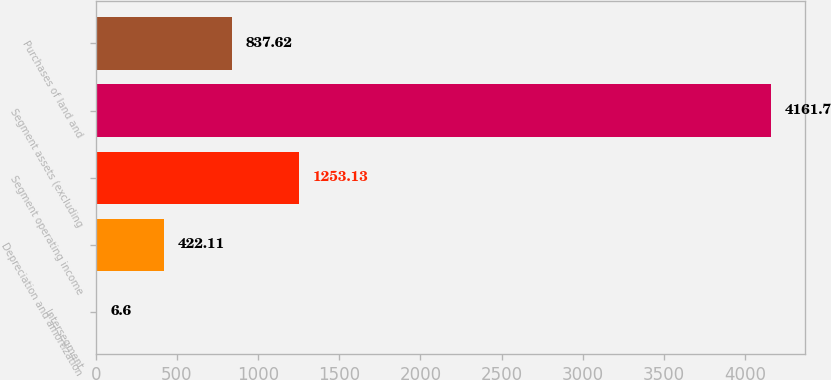Convert chart. <chart><loc_0><loc_0><loc_500><loc_500><bar_chart><fcel>Intersegment<fcel>Depreciation and amortization<fcel>Segment operating income<fcel>Segment assets (excluding<fcel>Purchases of land and<nl><fcel>6.6<fcel>422.11<fcel>1253.13<fcel>4161.7<fcel>837.62<nl></chart> 